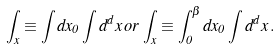Convert formula to latex. <formula><loc_0><loc_0><loc_500><loc_500>\int _ { x } \equiv \int d x _ { 0 } \int d ^ { d } x \, o r \, \int _ { x } \equiv \int _ { 0 } ^ { \beta } d x _ { 0 } \int d ^ { d } x \, .</formula> 